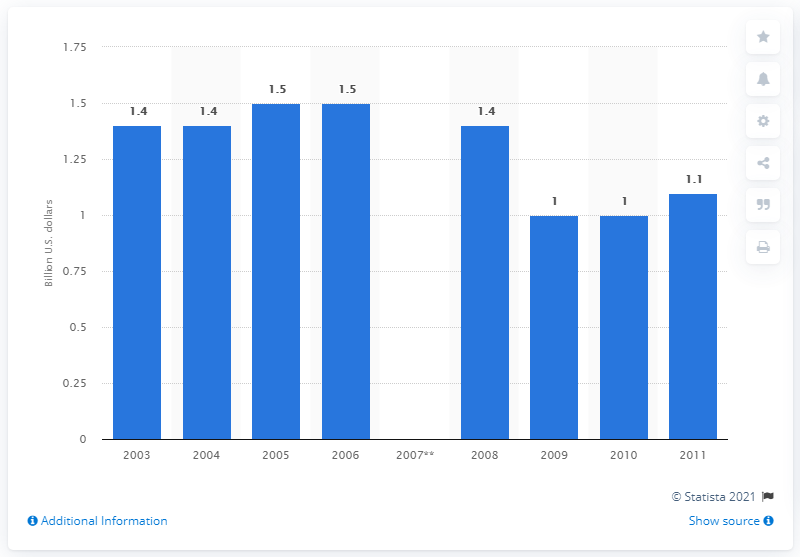Mention a couple of crucial points in this snapshot. The value of U.S. product shipments of toothpaste in 2009 was approximately 1.. 